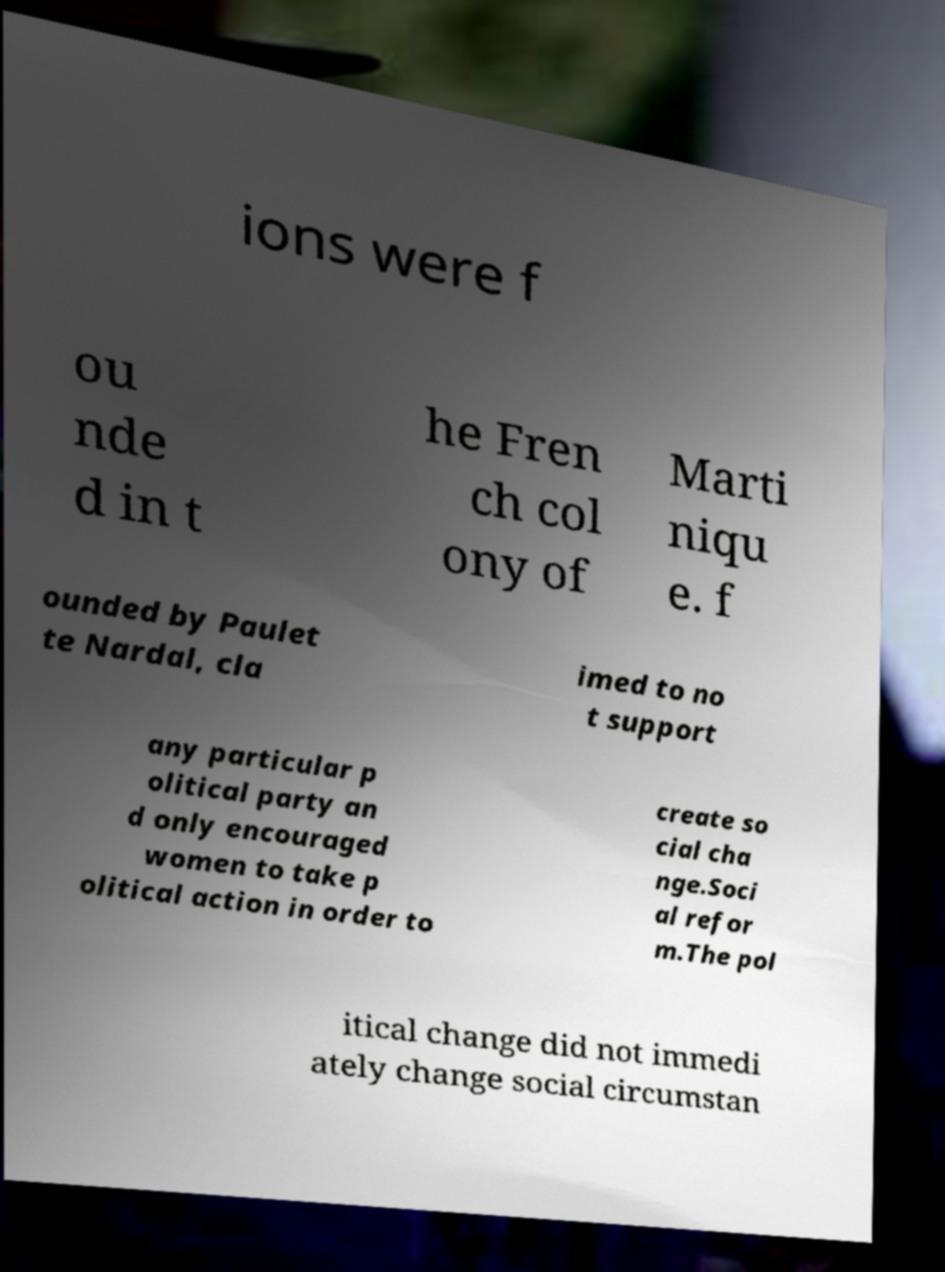Could you assist in decoding the text presented in this image and type it out clearly? ions were f ou nde d in t he Fren ch col ony of Marti niqu e. f ounded by Paulet te Nardal, cla imed to no t support any particular p olitical party an d only encouraged women to take p olitical action in order to create so cial cha nge.Soci al refor m.The pol itical change did not immedi ately change social circumstan 